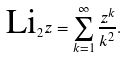<formula> <loc_0><loc_0><loc_500><loc_500>\text {Li} _ { 2 } z = \sum _ { k = 1 } ^ { \infty } \frac { z ^ { k } } { k ^ { 2 } } .</formula> 